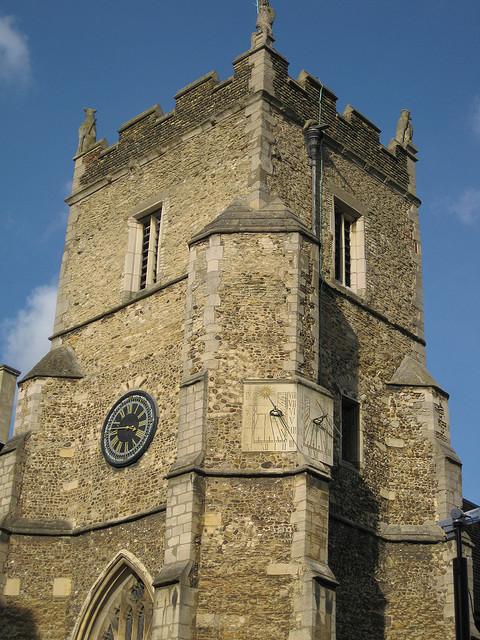Is there a bell in the tower?
Be succinct. No. How many windows on this tower?
Quick response, please. 2. Is this building old or new?
Short answer required. Old. What is the time difference between the clock on the far right and the clock on the far left?
Short answer required. 1 hour. Are there flowers in this picture?
Be succinct. No. What is this object?
Give a very brief answer. Building. Is there a bird flying?
Be succinct. No. How many windows are visible?
Short answer required. 3. Could this clock have animated figures?
Quick response, please. No. How many windows are above the clock?
Be succinct. 1. 